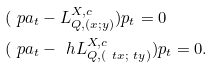Convert formula to latex. <formula><loc_0><loc_0><loc_500><loc_500>& ( \ p a _ { t } - L ^ { X , c } _ { Q , ( x ; y ) } ) p _ { t } = 0 \\ & ( \ p a _ { t } - \ h L ^ { X , c } _ { Q , ( \ t x ; \ t y ) } ) p _ { t } = 0 .</formula> 